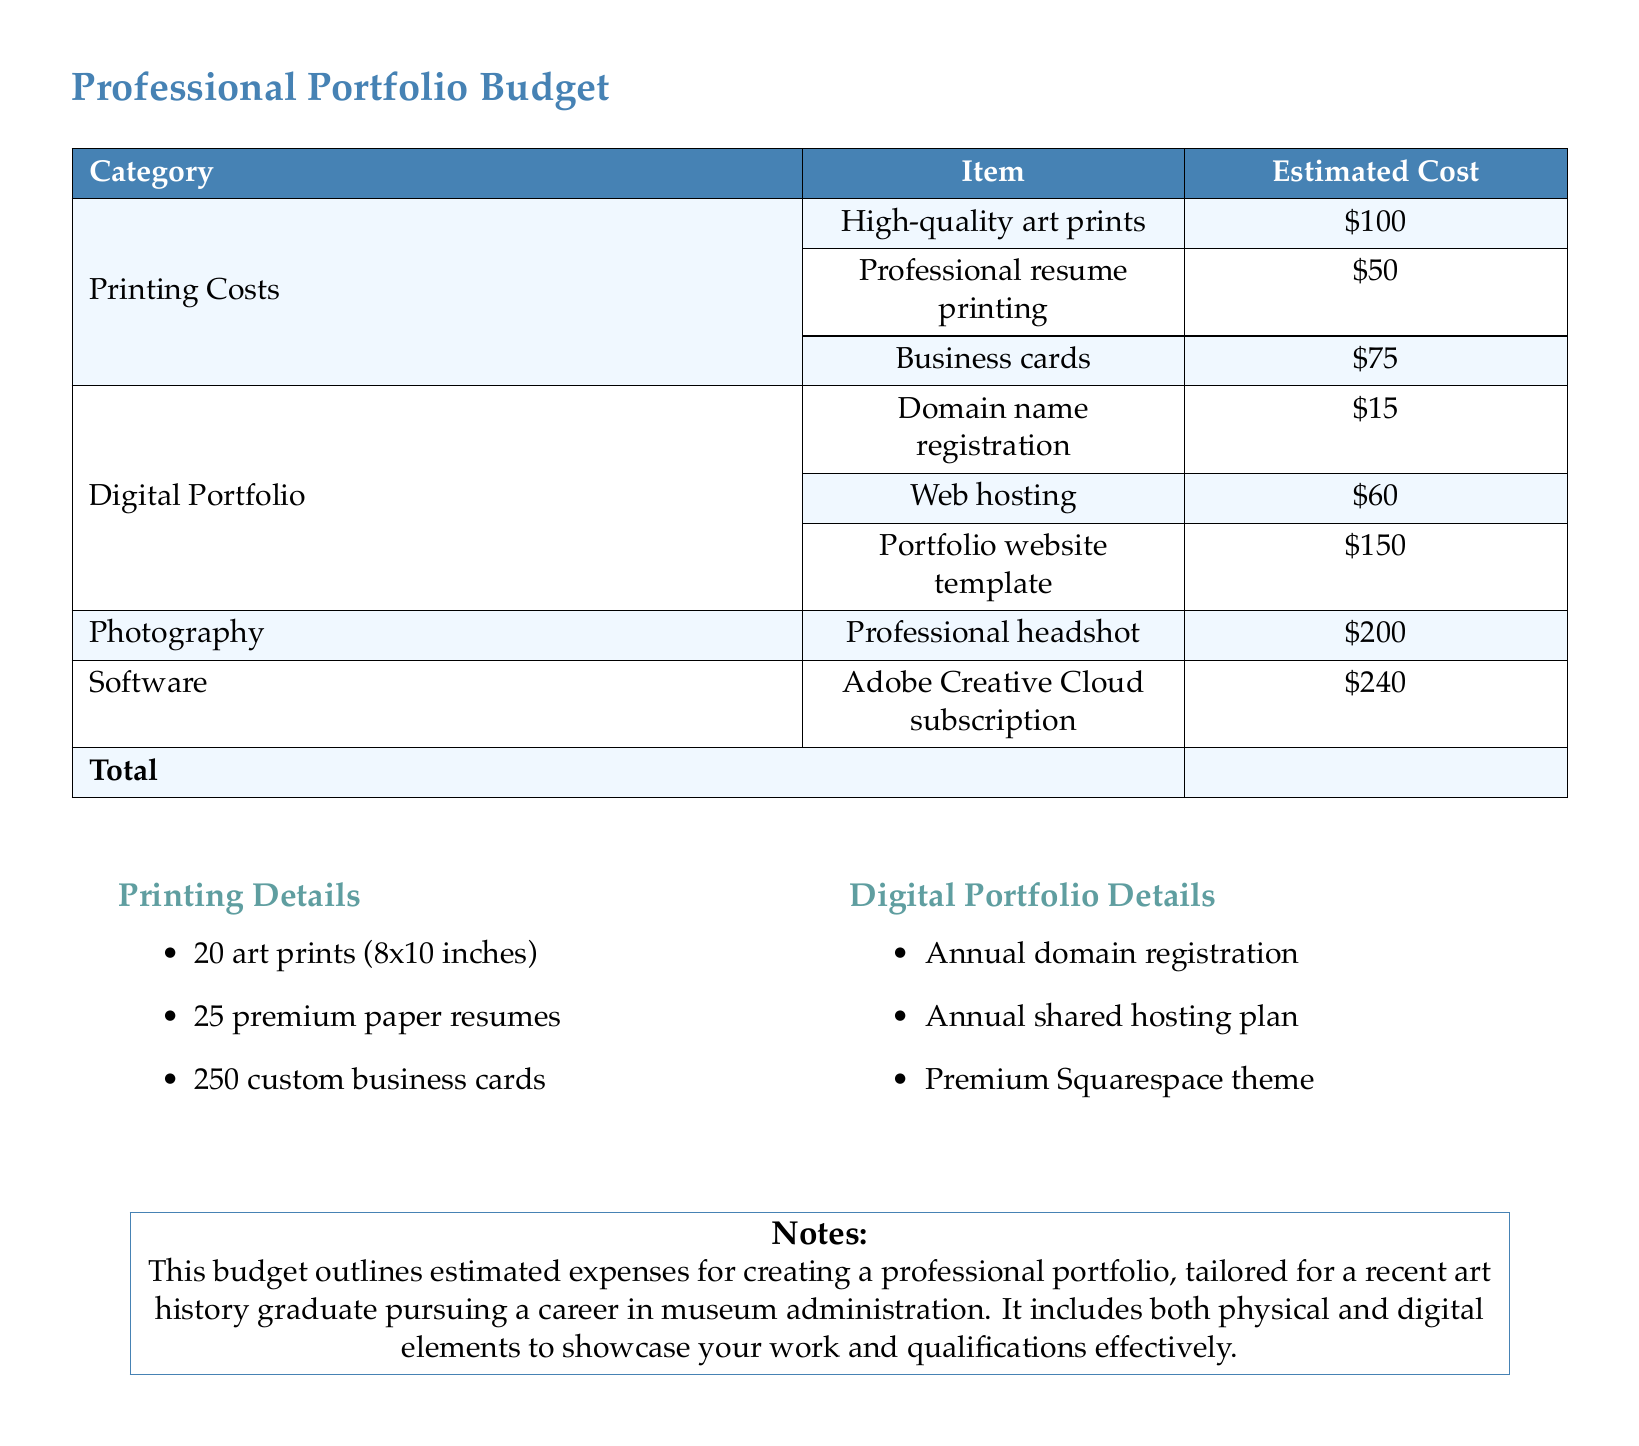What is the estimated total cost for the professional portfolio? The total cost is provided as the sum of all expenses listed in the budget.
Answer: $890 How much does the professional headshot cost? The document lists the expense specifically for the professional headshot.
Answer: $200 What is the cost for domain name registration? The budget includes an individual line item for domain name registration.
Answer: $15 How many business cards are included in the printing costs? The detailed printing section specifies the quantity of business cards.
Answer: 250 What type of software subscription is included in the budget? The document mentions a specific software subscription needed for the portfolio.
Answer: Adobe Creative Cloud How much does the web hosting fee amount to? The document provides a specific expense related to web hosting in the digital portfolio section.
Answer: $60 What are the total printing costs for art prints, resumes, and business cards? The individual costs for each printing item can be added to find the total.
Answer: $225 What is the cost of the portfolio website template? The budget specifies an expense for the website template separately.
Answer: $150 What kind of printing materials are included in the budget? The printing section lists types such as art prints, resumes, and business cards.
Answer: High-quality art prints, professional resume printing, business cards What year is the domain registration valid for? The budget notes that the domain registration is listed as an annual expense.
Answer: Annual 